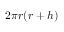Convert formula to latex. <formula><loc_0><loc_0><loc_500><loc_500>2 \pi r ( r + h )</formula> 